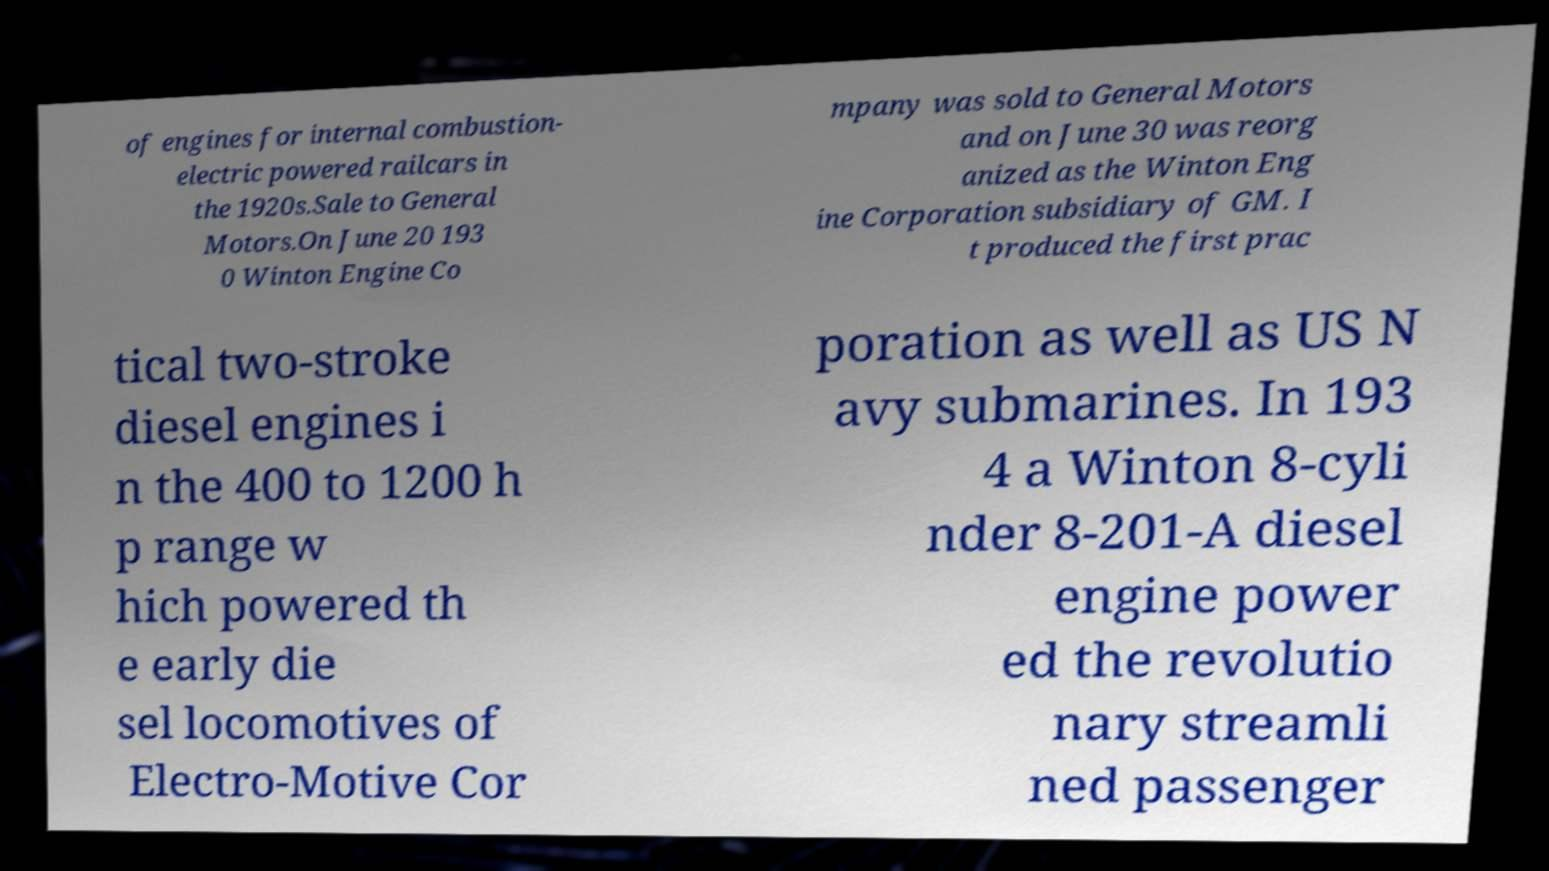Could you extract and type out the text from this image? of engines for internal combustion- electric powered railcars in the 1920s.Sale to General Motors.On June 20 193 0 Winton Engine Co mpany was sold to General Motors and on June 30 was reorg anized as the Winton Eng ine Corporation subsidiary of GM. I t produced the first prac tical two-stroke diesel engines i n the 400 to 1200 h p range w hich powered th e early die sel locomotives of Electro-Motive Cor poration as well as US N avy submarines. In 193 4 a Winton 8-cyli nder 8-201-A diesel engine power ed the revolutio nary streamli ned passenger 